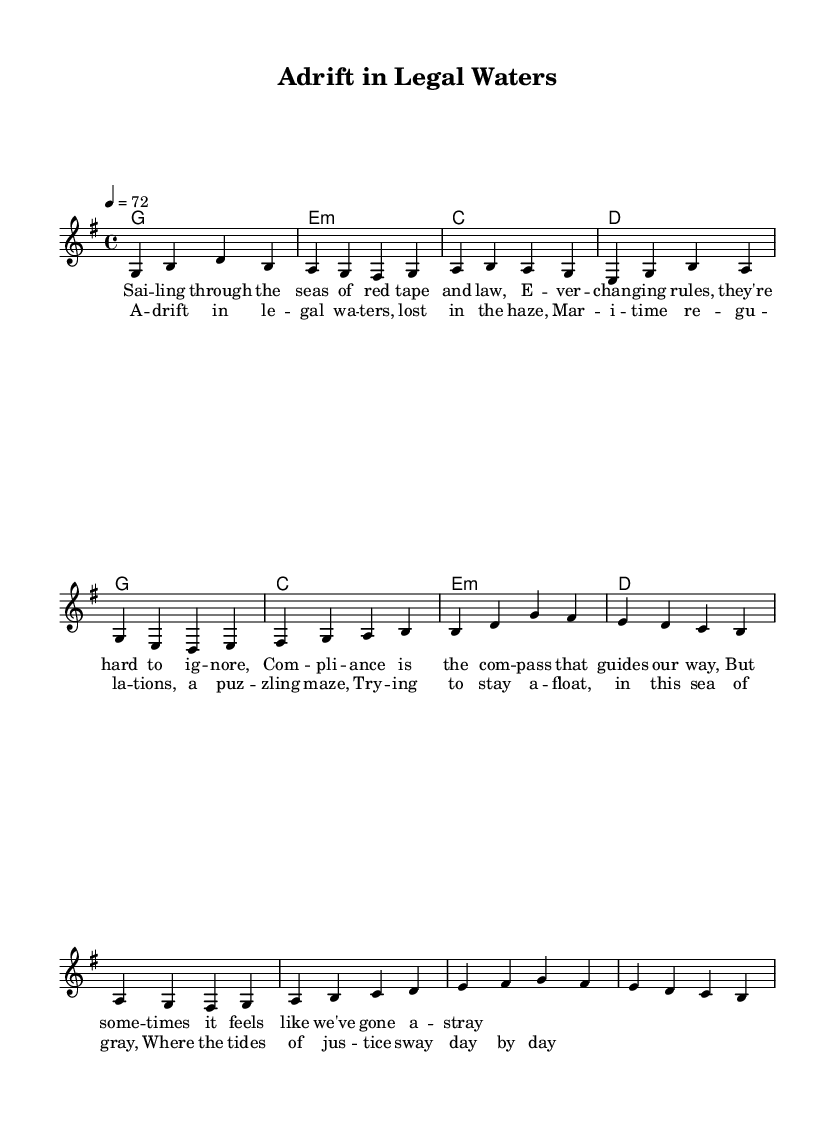What is the key signature of this music? The key signature is indicated by the sharp symbols at the beginning of the staff. There is one sharp, which corresponds to the key of G major.
Answer: G major What is the time signature of this music? The time signature is indicated by the numbers at the beginning of the staff. It shows 4 beats in each measure, represented by 4/4.
Answer: 4/4 What is the tempo marking for this piece? The tempo is shown at the beginning of the music as a number indicating beats per minute. It is marked as 4 equals 72, meaning there are 72 beats per minute.
Answer: 72 How many measures are in the verse? The verse section is counted by examining the bar lines that separate the measures. There are 6 measures in the verse.
Answer: 6 What is the first chord in the verse? The first chord is found in the chord section above the melody. The first labeled chord in the verse is G major.
Answer: G What word describes the overall mood of the lyrics? The lyrics reflect themes of confusion and difficulty, as indicated by words like "adrift" and "haze." The overall mood conveyed is melancholic.
Answer: Melancholic What is the rhyme scheme of the chorus? The rhyme scheme can be determined by examining the end words of each line in the chorus. They follow an "AABB" pattern, as lines 1 and 2 rhyme with each other, and lines 3 and 4 have a different rhyme.
Answer: AABB 